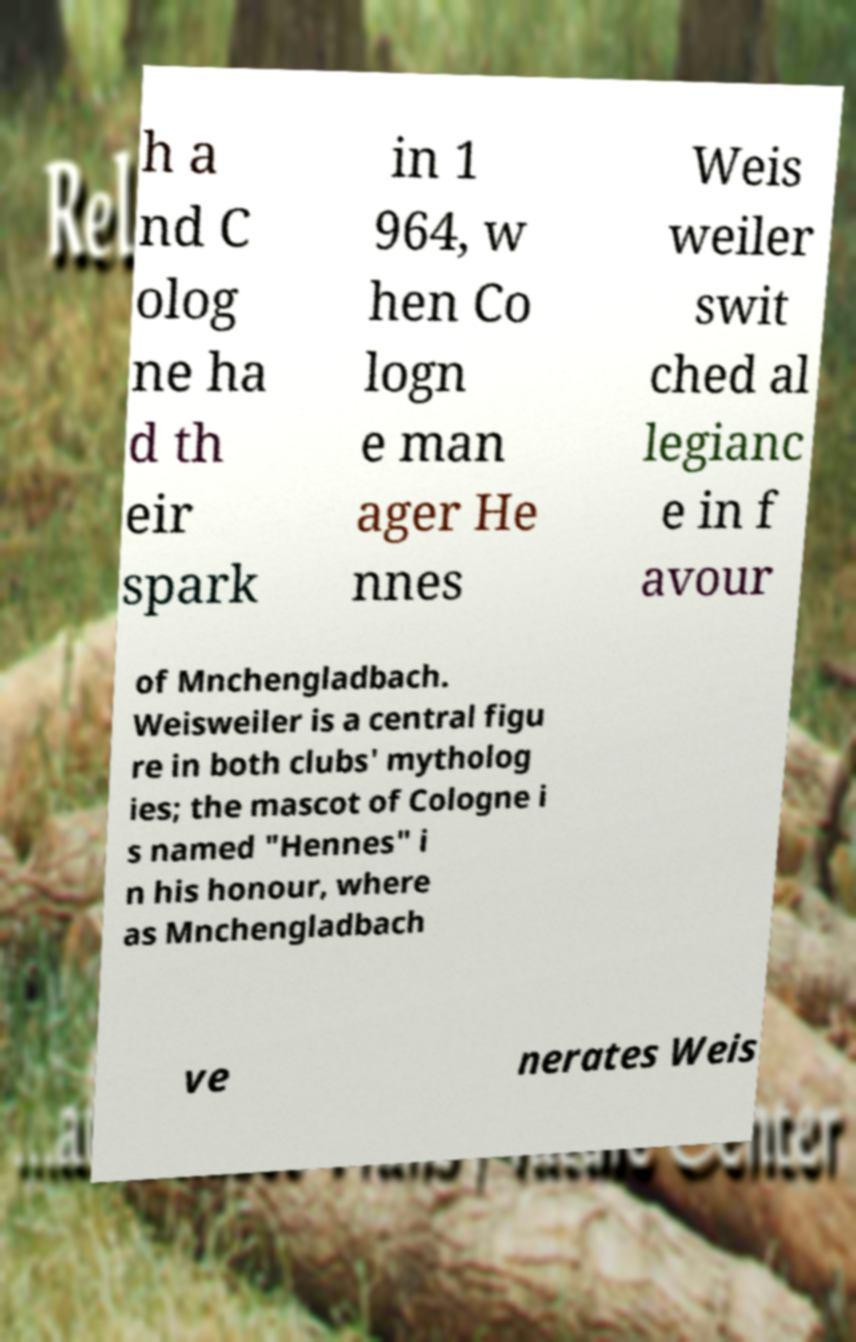Please identify and transcribe the text found in this image. h a nd C olog ne ha d th eir spark in 1 964, w hen Co logn e man ager He nnes Weis weiler swit ched al legianc e in f avour of Mnchengladbach. Weisweiler is a central figu re in both clubs' mytholog ies; the mascot of Cologne i s named "Hennes" i n his honour, where as Mnchengladbach ve nerates Weis 